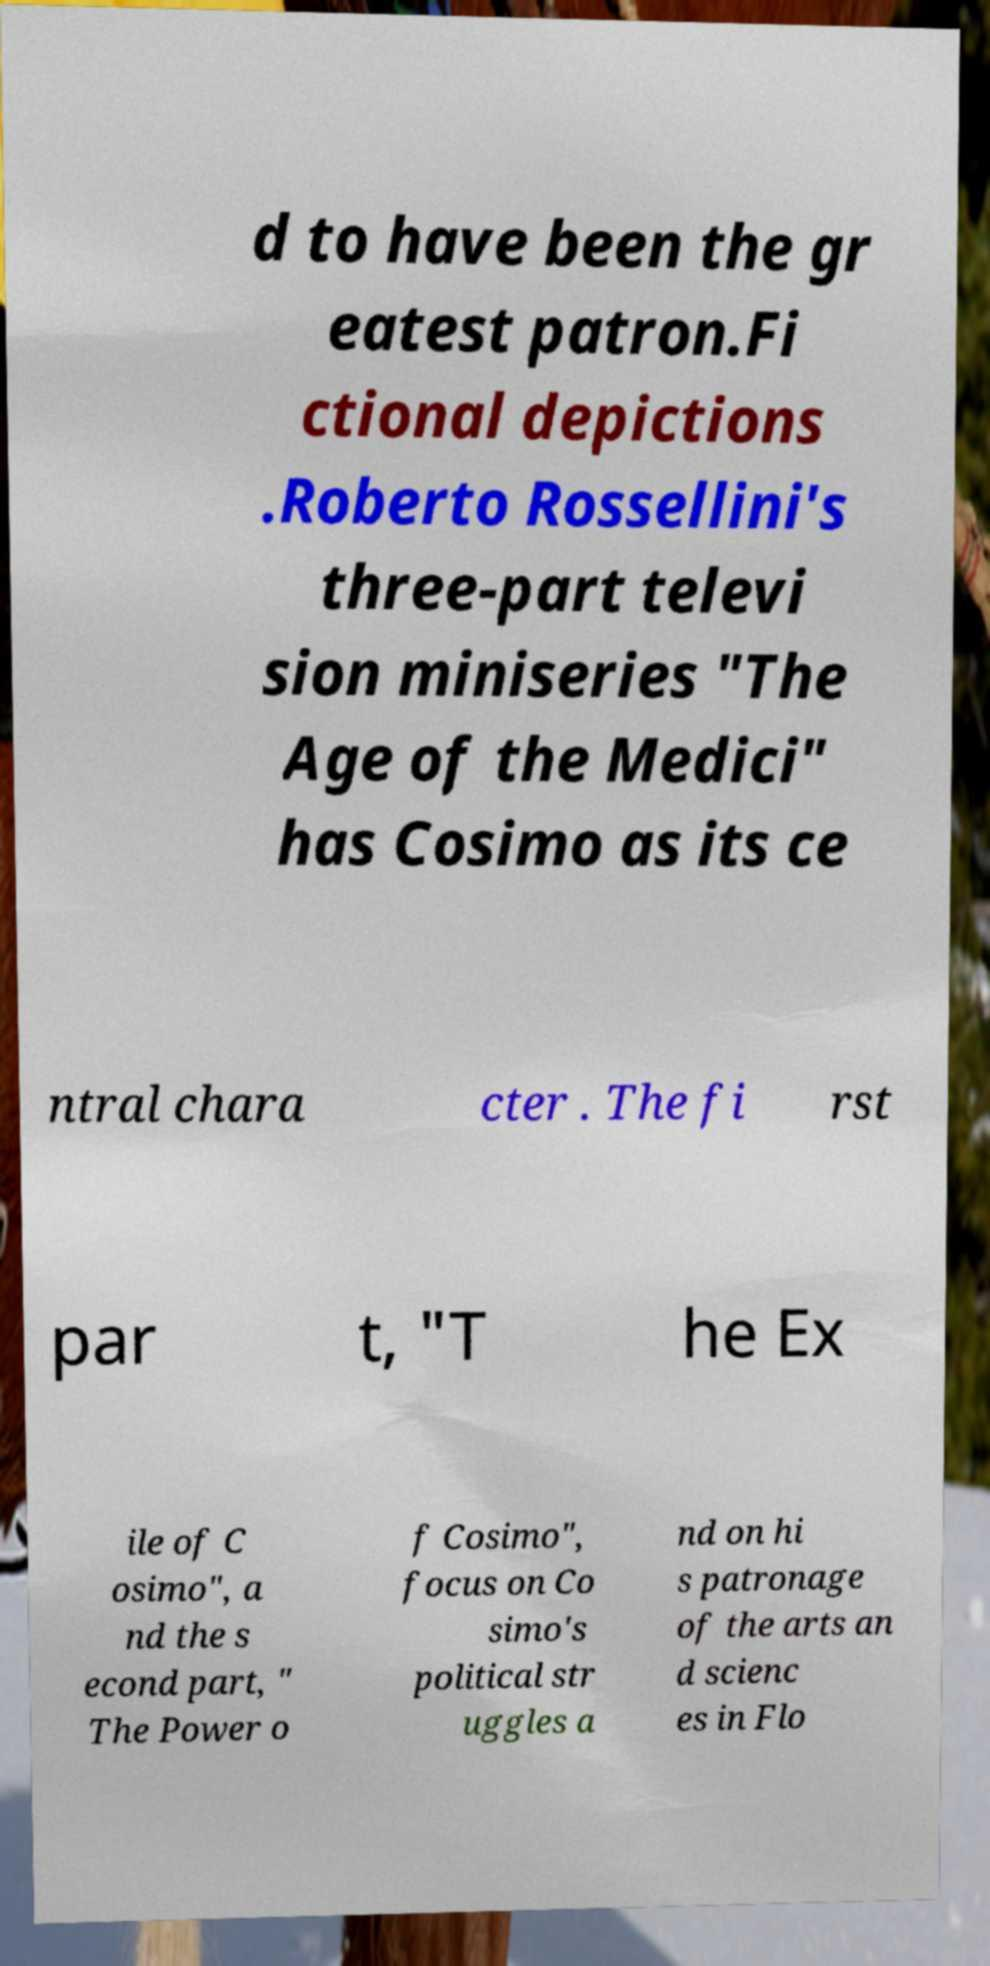Please read and relay the text visible in this image. What does it say? d to have been the gr eatest patron.Fi ctional depictions .Roberto Rossellini's three-part televi sion miniseries "The Age of the Medici" has Cosimo as its ce ntral chara cter . The fi rst par t, "T he Ex ile of C osimo", a nd the s econd part, " The Power o f Cosimo", focus on Co simo's political str uggles a nd on hi s patronage of the arts an d scienc es in Flo 